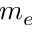<formula> <loc_0><loc_0><loc_500><loc_500>m _ { e }</formula> 